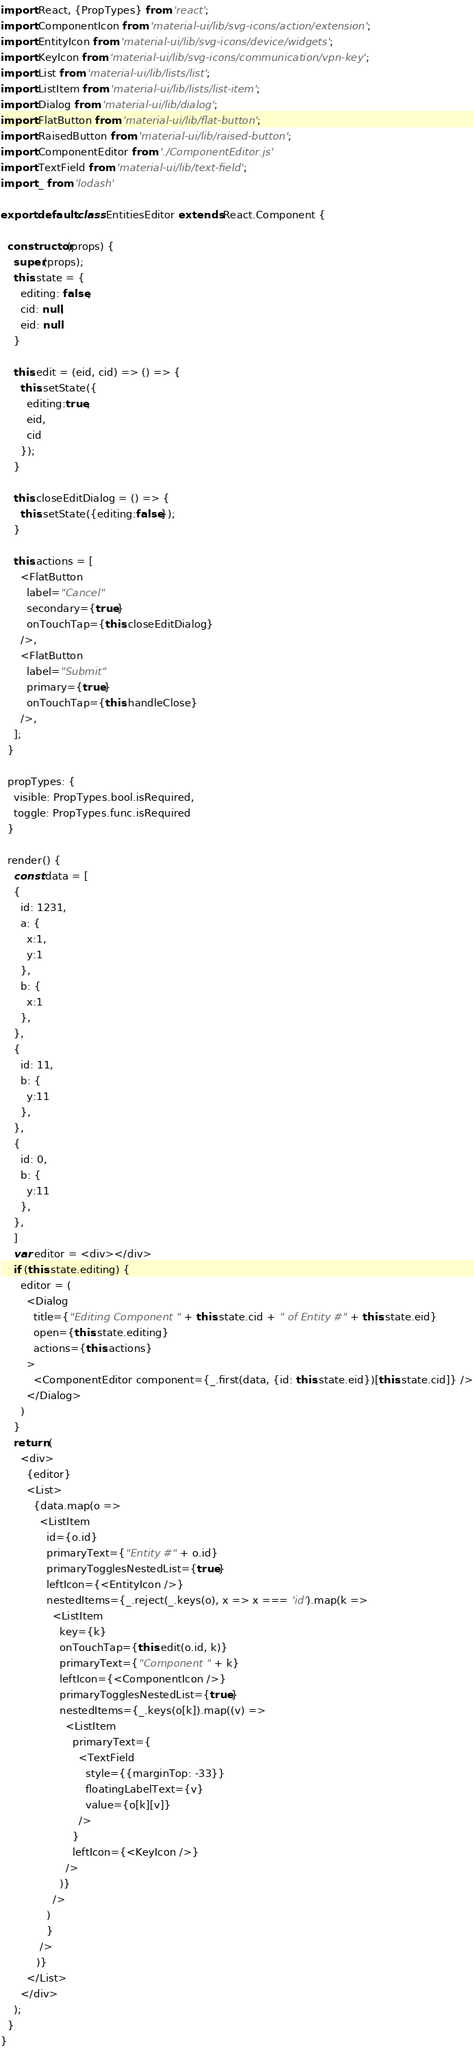<code> <loc_0><loc_0><loc_500><loc_500><_JavaScript_>import React, {PropTypes} from 'react';
import ComponentIcon from 'material-ui/lib/svg-icons/action/extension';
import EntityIcon from 'material-ui/lib/svg-icons/device/widgets';
import KeyIcon from 'material-ui/lib/svg-icons/communication/vpn-key';
import List from 'material-ui/lib/lists/list';
import ListItem from 'material-ui/lib/lists/list-item';
import Dialog from 'material-ui/lib/dialog';
import FlatButton from 'material-ui/lib/flat-button';
import RaisedButton from 'material-ui/lib/raised-button';
import ComponentEditor from './ComponentEditor.js'
import TextField from 'material-ui/lib/text-field';
import _ from 'lodash'

export default class EntitiesEditor extends React.Component {

  constructor(props) {
    super(props);
    this.state = {
      editing: false,
      cid: null,
      eid: null
    }

    this.edit = (eid, cid) => () => {
      this.setState({
        editing:true,
        eid,
        cid
      });
    }

    this.closeEditDialog = () => {
      this.setState({editing:false});
    }

    this.actions = [
      <FlatButton
        label="Cancel"
        secondary={true}
        onTouchTap={this.closeEditDialog}
      />,
      <FlatButton
        label="Submit"
        primary={true}
        onTouchTap={this.handleClose}
      />,
    ];
  }

  propTypes: {
    visible: PropTypes.bool.isRequired,
    toggle: PropTypes.func.isRequired
  }

  render() {
    const data = [
    {
      id: 1231,
      a: {
        x:1,
        y:1
      },
      b: {
        x:1
      },
    },
    {
      id: 11,
      b: {
        y:11
      },
    },
    {
      id: 0,
      b: {
        y:11
      },
    },
    ]
    var editor = <div></div>
    if (this.state.editing) {
      editor = (
        <Dialog
          title={"Editing Component " + this.state.cid + " of Entity #" + this.state.eid}
          open={this.state.editing}
          actions={this.actions}
        >
          <ComponentEditor component={_.first(data, {id: this.state.eid})[this.state.cid]} />
        </Dialog>
      )
    }
    return (
      <div>
        {editor}
        <List>
          {data.map(o => 
            <ListItem
              id={o.id}
              primaryText={"Entity #" + o.id}
              primaryTogglesNestedList={true}
              leftIcon={<EntityIcon />}
              nestedItems={_.reject(_.keys(o), x => x === 'id').map(k => 
                <ListItem
                  key={k}
                  onTouchTap={this.edit(o.id, k)}
                  primaryText={"Component " + k}
                  leftIcon={<ComponentIcon />}
                  primaryTogglesNestedList={true}
                  nestedItems={_.keys(o[k]).map((v) => 
                    <ListItem
                      primaryText={
                        <TextField
                          style={{marginTop: -33}}
                          floatingLabelText={v}
                          value={o[k][v]}
                        />
                      }
                      leftIcon={<KeyIcon />}
                    />
                  )}
                />
              )
              }
            />
           )}
        </List>
      </div>
    );
  }
}
</code> 